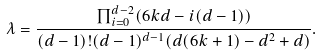<formula> <loc_0><loc_0><loc_500><loc_500>\lambda = \frac { \prod _ { i = 0 } ^ { d - 2 } ( 6 k d - i ( d - 1 ) ) } { ( d - 1 ) ! ( d - 1 ) ^ { d - 1 } ( d ( 6 k + 1 ) - d ^ { 2 } + d ) } .</formula> 